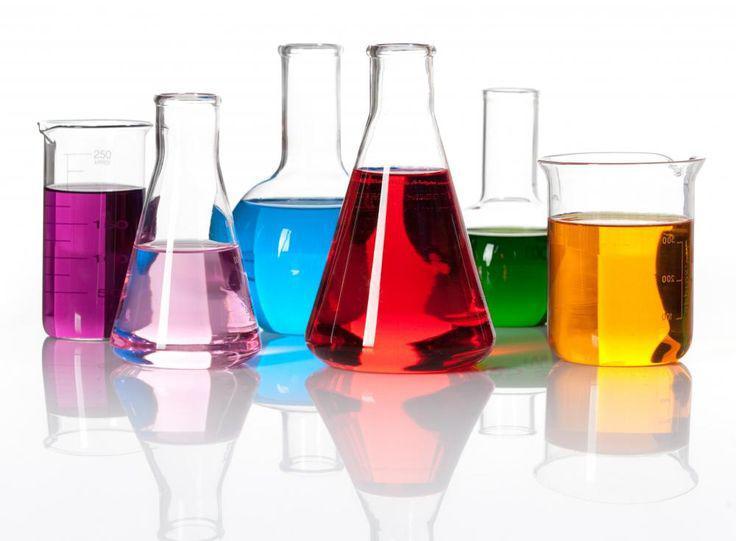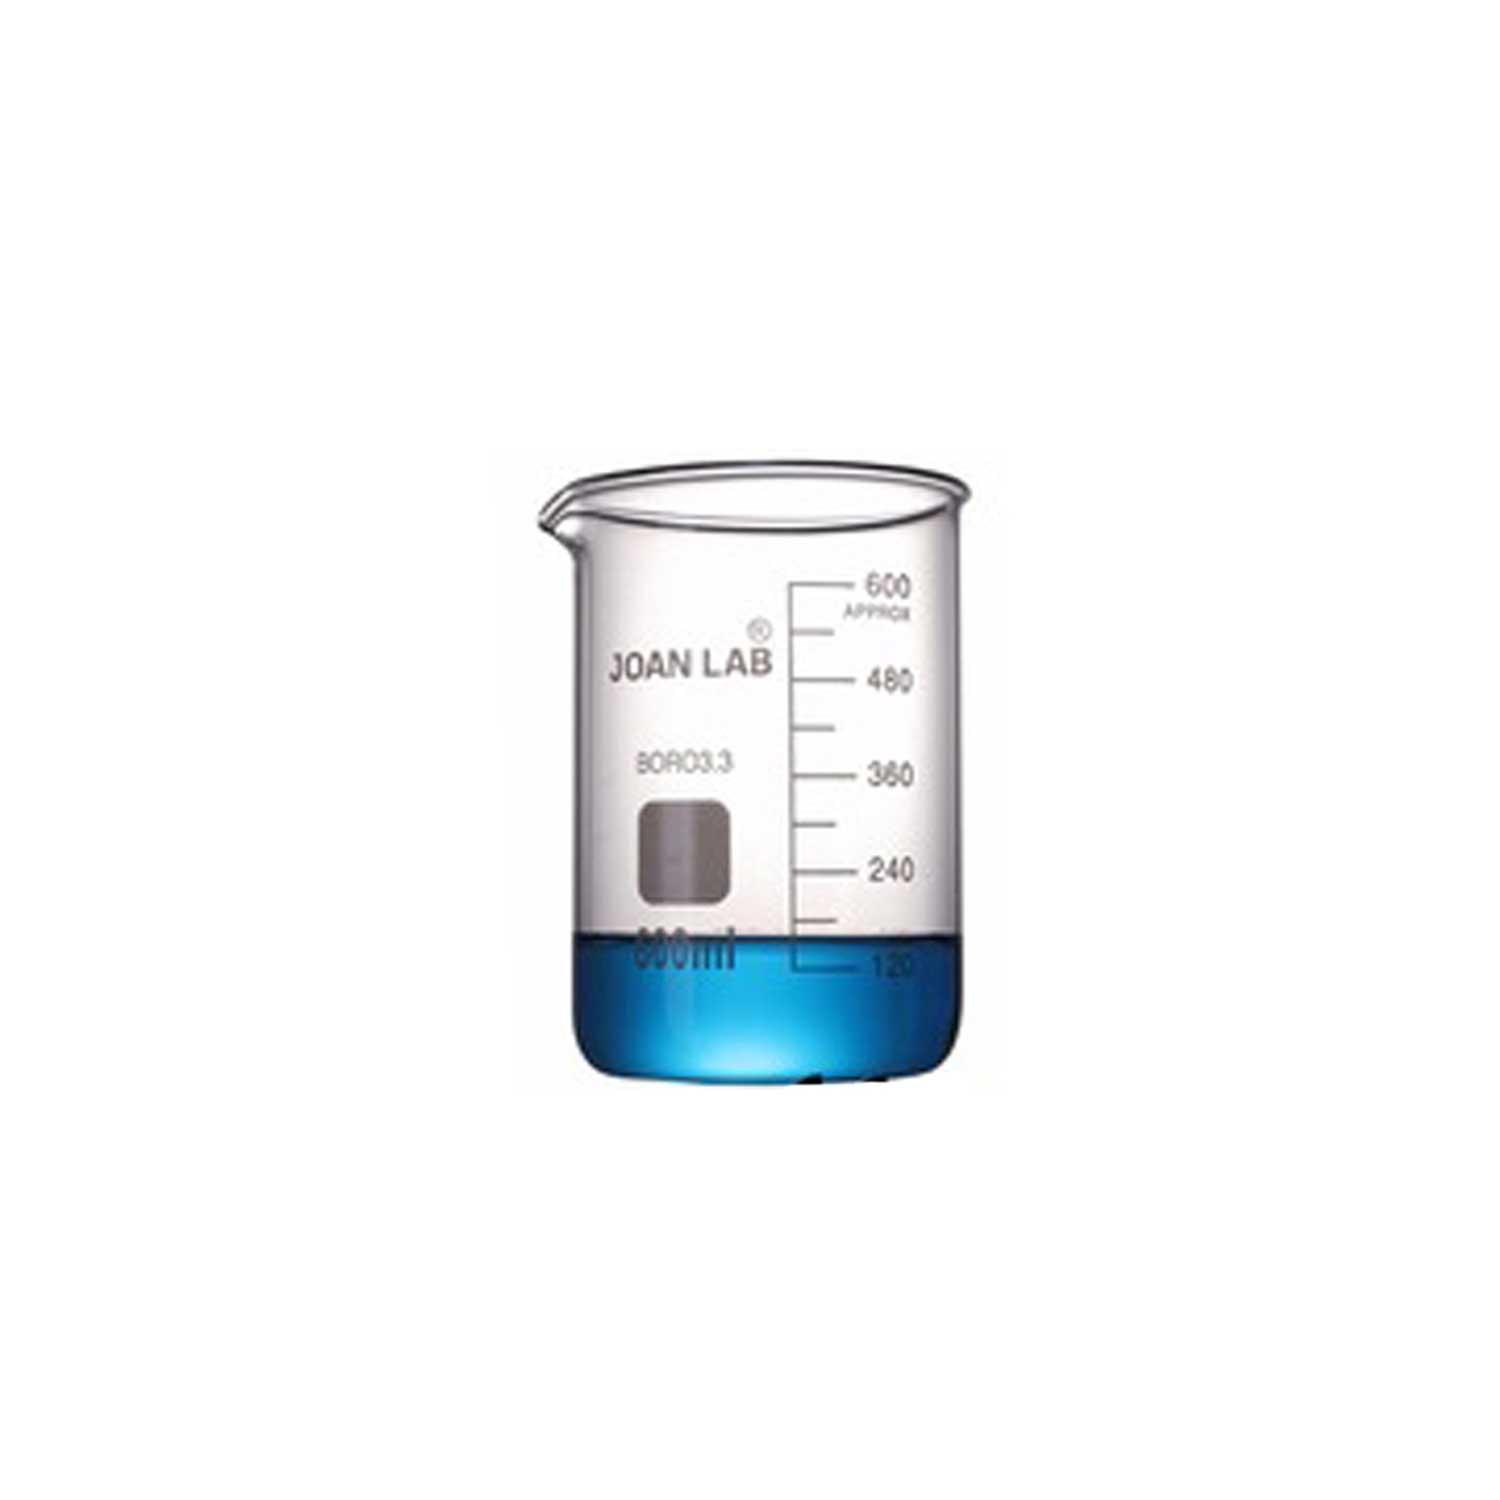The first image is the image on the left, the second image is the image on the right. Examine the images to the left and right. Is the description "One of the liquids is green." accurate? Answer yes or no. Yes. The first image is the image on the left, the second image is the image on the right. Assess this claim about the two images: "There is only one beaker in one of the images, and it has some liquid inside it.". Correct or not? Answer yes or no. Yes. 